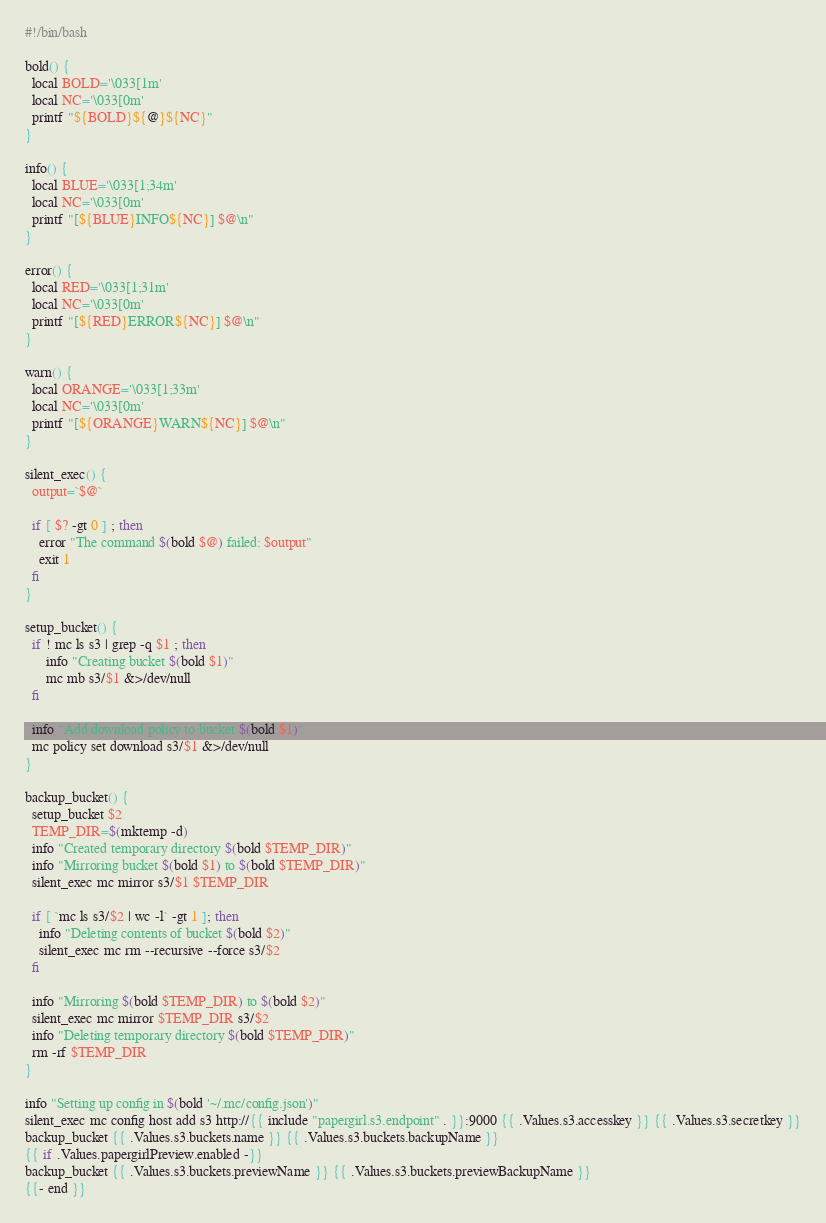<code> <loc_0><loc_0><loc_500><loc_500><_Bash_>#!/bin/bash

bold() {
  local BOLD='\033[1m'
  local NC='\033[0m'
  printf "${BOLD}${@}${NC}"
}

info() {
  local BLUE='\033[1;34m'
  local NC='\033[0m'
  printf "[${BLUE}INFO${NC}] $@\n"
}

error() {
  local RED='\033[1;31m'
  local NC='\033[0m'
  printf "[${RED}ERROR${NC}] $@\n"
}

warn() {
  local ORANGE='\033[1;33m'
  local NC='\033[0m'
  printf "[${ORANGE}WARN${NC}] $@\n"
}

silent_exec() {
  output=`$@`

  if [ $? -gt 0 ] ; then
    error "The command $(bold $@) failed: $output"
    exit 1
  fi
}

setup_bucket() {
  if ! mc ls s3 | grep -q $1 ; then
      info "Creating bucket $(bold $1)"
      mc mb s3/$1 &>/dev/null
  fi

  info "Add download policy to bucket $(bold $1)"
  mc policy set download s3/$1 &>/dev/null
}

backup_bucket() {
  setup_bucket $2
  TEMP_DIR=$(mktemp -d)
  info "Created temporary directory $(bold $TEMP_DIR)"
  info "Mirroring bucket $(bold $1) to $(bold $TEMP_DIR)"
  silent_exec mc mirror s3/$1 $TEMP_DIR

  if [ `mc ls s3/$2 | wc -l` -gt 1 ]; then
    info "Deleting contents of bucket $(bold $2)"
    silent_exec mc rm --recursive --force s3/$2
  fi

  info "Mirroring $(bold $TEMP_DIR) to $(bold $2)"
  silent_exec mc mirror $TEMP_DIR s3/$2
  info "Deleting temporary directory $(bold $TEMP_DIR)"
  rm -rf $TEMP_DIR
}

info "Setting up config in $(bold '~/.mc/config.json')"
silent_exec mc config host add s3 http://{{ include "papergirl.s3.endpoint" . }}:9000 {{ .Values.s3.accesskey }} {{ .Values.s3.secretkey }}
backup_bucket {{ .Values.s3.buckets.name }} {{ .Values.s3.buckets.backupName }}
{{ if .Values.papergirlPreview.enabled -}}
backup_bucket {{ .Values.s3.buckets.previewName }} {{ .Values.s3.buckets.previewBackupName }}
{{- end }}


</code> 